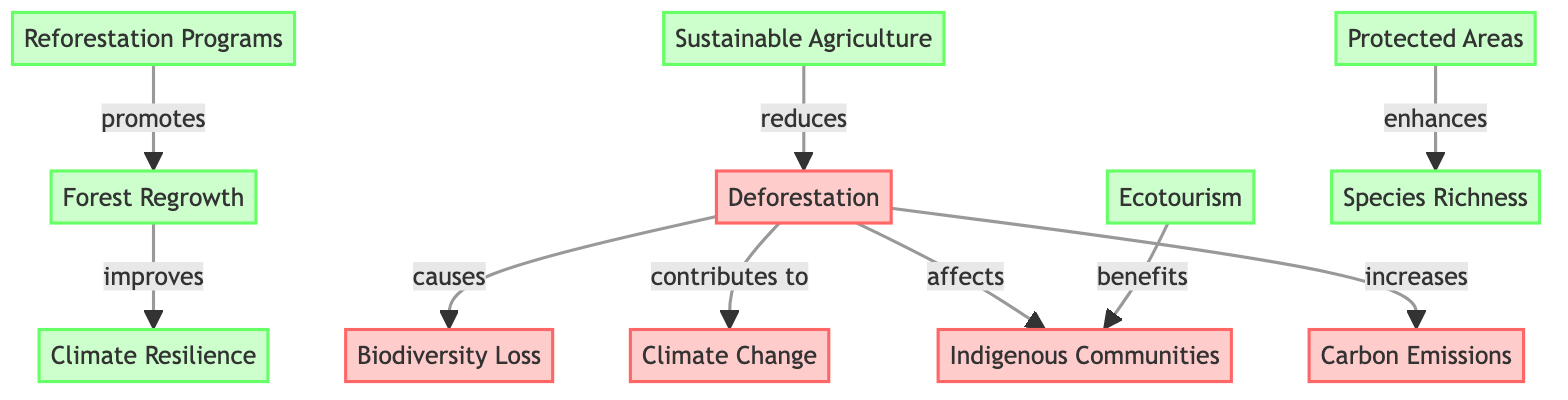What is the first node in the diagram? The first node in the diagram is labeled "Deforestation," which serves as the starting point for understanding the various effects and restoration strategies.
Answer: Deforestation How many effects are listed in the diagram? The diagram shows five distinct effects stemming from deforestation, which include biodiversity loss, climate change, effects on indigenous communities, and carbon emissions.
Answer: 4 What do reforestation programs promote? Reforestation programs promote forest regrowth, indicating a direct benefit of implementing these initiatives in response to deforestation.
Answer: Forest Regrowth How does sustainable agriculture relate to deforestation? The relationship is that sustainable agriculture reduces deforestation, suggesting it is a solution that addresses one of the primary causes of the environmental issue depicted.
Answer: Reduces Which solution enhances species richness? The solution that enhances species richness is the establishment of protected areas, which helps preserve various species within the ecosystem.
Answer: Protected Areas What is the final outcome of forest regrowth according to the diagram? The final outcome of forest regrowth is an improvement in climate resilience, demonstrating the positive environmental impact of allowing forests to regenerate.
Answer: Climate Resilience What connects "Deforestation" to "Biodiversity Loss"? The connecting phrase in the diagram indicates that deforestation causes biodiversity loss, showing the direct impact of decreased forest areas on wildlife diversity.
Answer: Causes Which strategies benefit indigenous communities? The strategy that benefits indigenous communities is ecotourism, indicating a socioeconomic benefit from sustainable practices.
Answer: Ecotourism How many strategies are listed to counteract deforestation? The diagram lists five distinct strategies to address deforestation, which are reforestation, protected areas, sustainable agriculture, ecotourism, and forest regrowth.
Answer: 5 